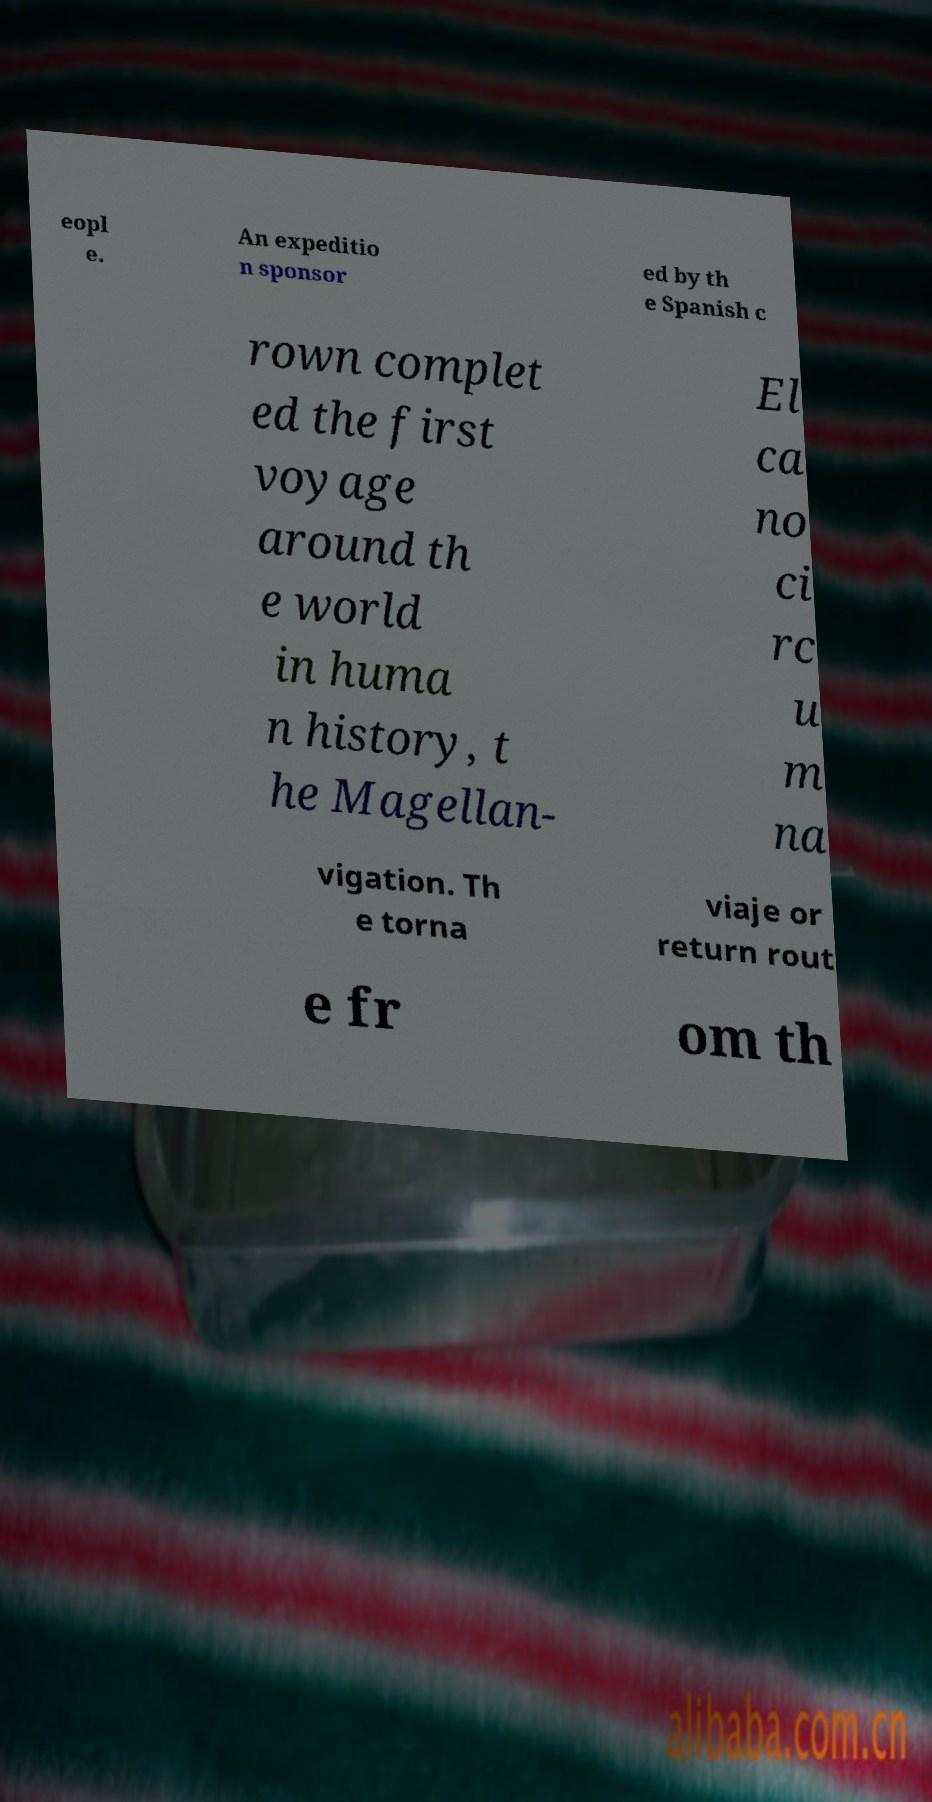Could you extract and type out the text from this image? eopl e. An expeditio n sponsor ed by th e Spanish c rown complet ed the first voyage around th e world in huma n history, t he Magellan- El ca no ci rc u m na vigation. Th e torna viaje or return rout e fr om th 